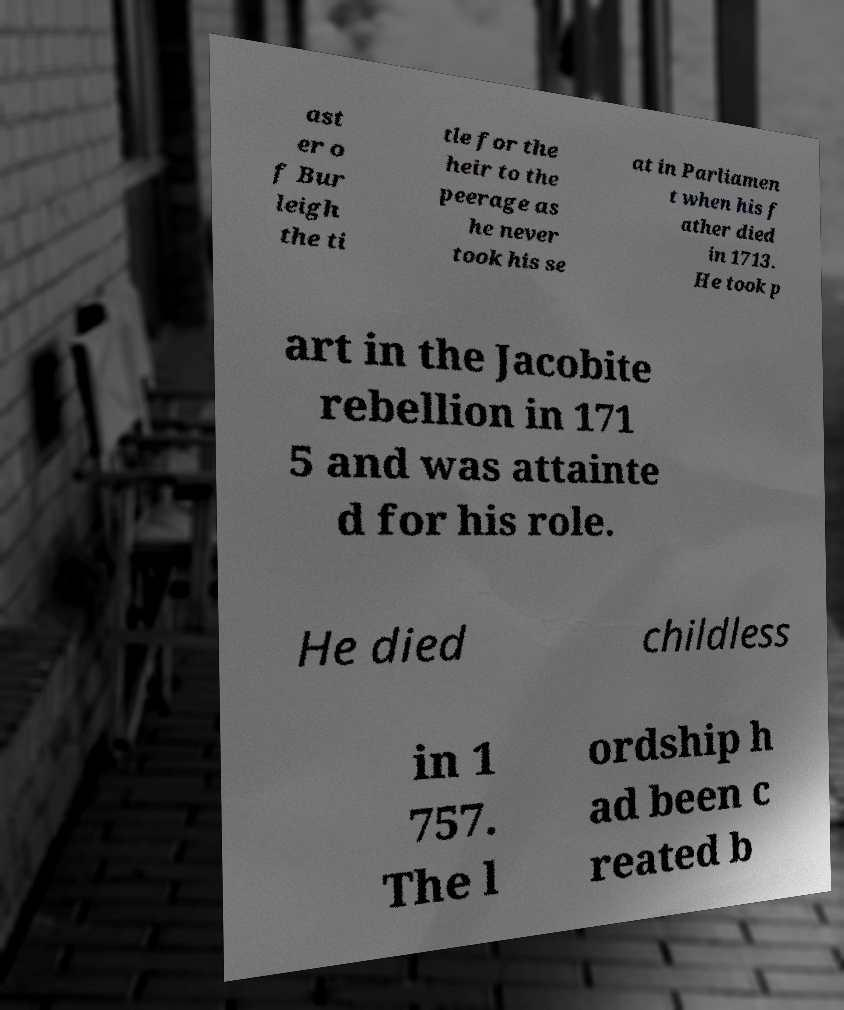I need the written content from this picture converted into text. Can you do that? ast er o f Bur leigh the ti tle for the heir to the peerage as he never took his se at in Parliamen t when his f ather died in 1713. He took p art in the Jacobite rebellion in 171 5 and was attainte d for his role. He died childless in 1 757. The l ordship h ad been c reated b 